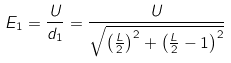<formula> <loc_0><loc_0><loc_500><loc_500>E _ { 1 } = \frac { U } { d _ { 1 } } = \frac { U } { \sqrt { \left ( \frac { L } { 2 } \right ) ^ { 2 } + \left ( \frac { L } { 2 } - 1 \right ) ^ { 2 } } }</formula> 